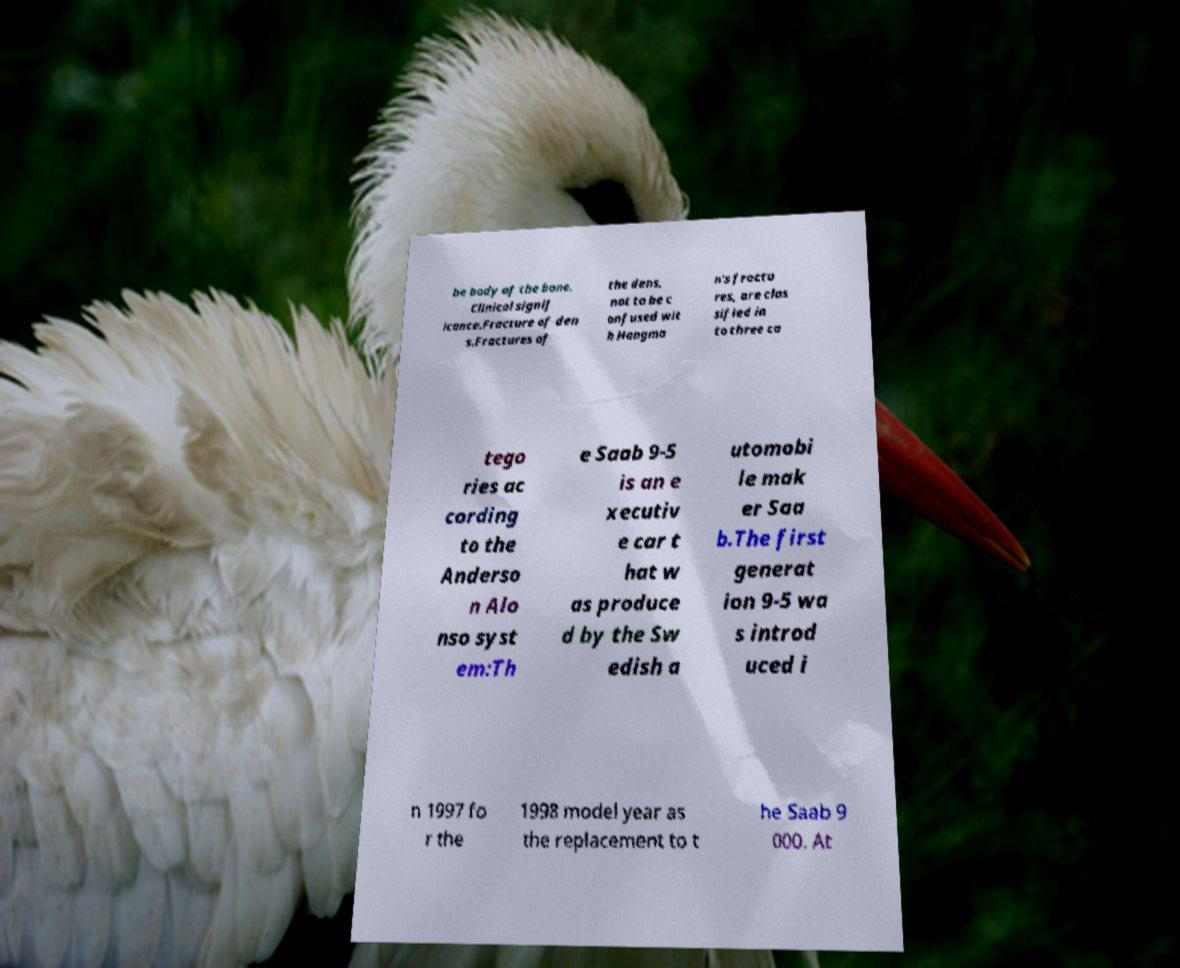Could you assist in decoding the text presented in this image and type it out clearly? he body of the bone. Clinical signif icance.Fracture of den s.Fractures of the dens, not to be c onfused wit h Hangma n's fractu res, are clas sified in to three ca tego ries ac cording to the Anderso n Alo nso syst em:Th e Saab 9-5 is an e xecutiv e car t hat w as produce d by the Sw edish a utomobi le mak er Saa b.The first generat ion 9-5 wa s introd uced i n 1997 fo r the 1998 model year as the replacement to t he Saab 9 000. At 